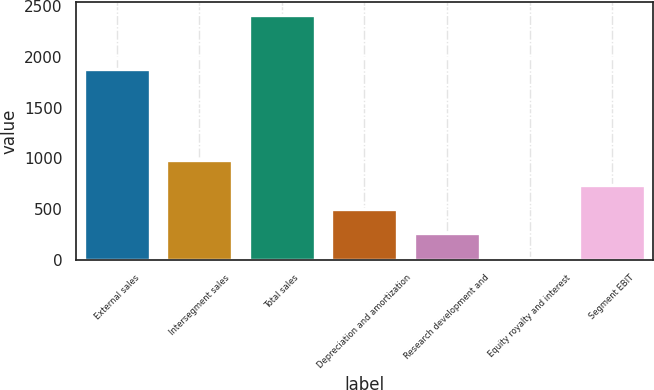Convert chart. <chart><loc_0><loc_0><loc_500><loc_500><bar_chart><fcel>External sales<fcel>Intersegment sales<fcel>Total sales<fcel>Depreciation and amortization<fcel>Research development and<fcel>Equity royalty and interest<fcel>Segment EBIT<nl><fcel>1879<fcel>980<fcel>2417<fcel>501<fcel>261.5<fcel>22<fcel>740.5<nl></chart> 